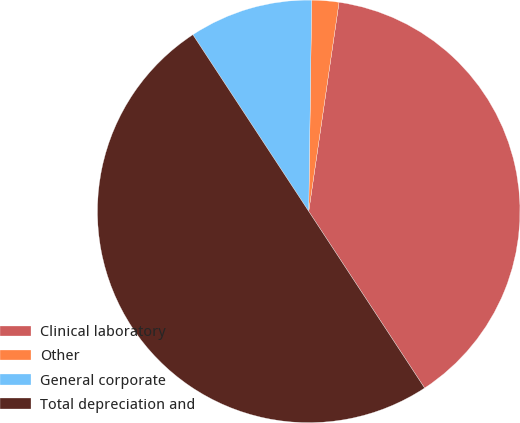<chart> <loc_0><loc_0><loc_500><loc_500><pie_chart><fcel>Clinical laboratory<fcel>Other<fcel>General corporate<fcel>Total depreciation and<nl><fcel>38.47%<fcel>2.07%<fcel>9.46%<fcel>50.0%<nl></chart> 